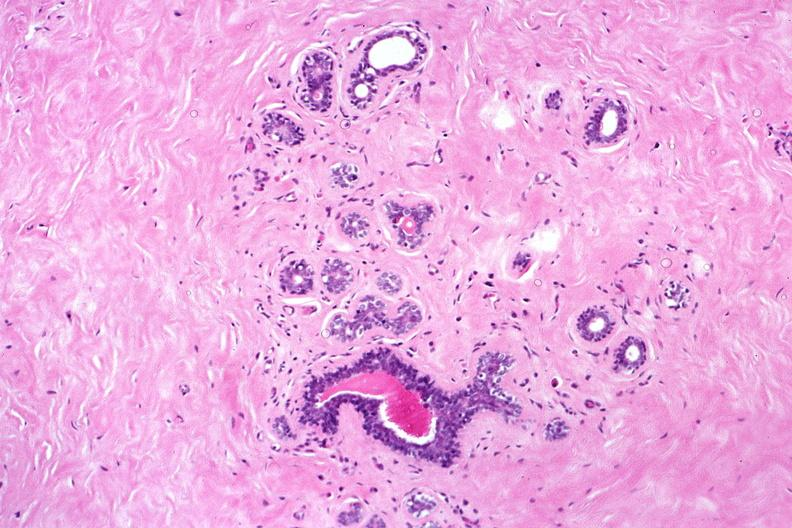where is this from?
Answer the question using a single word or phrase. Female reproductive system 